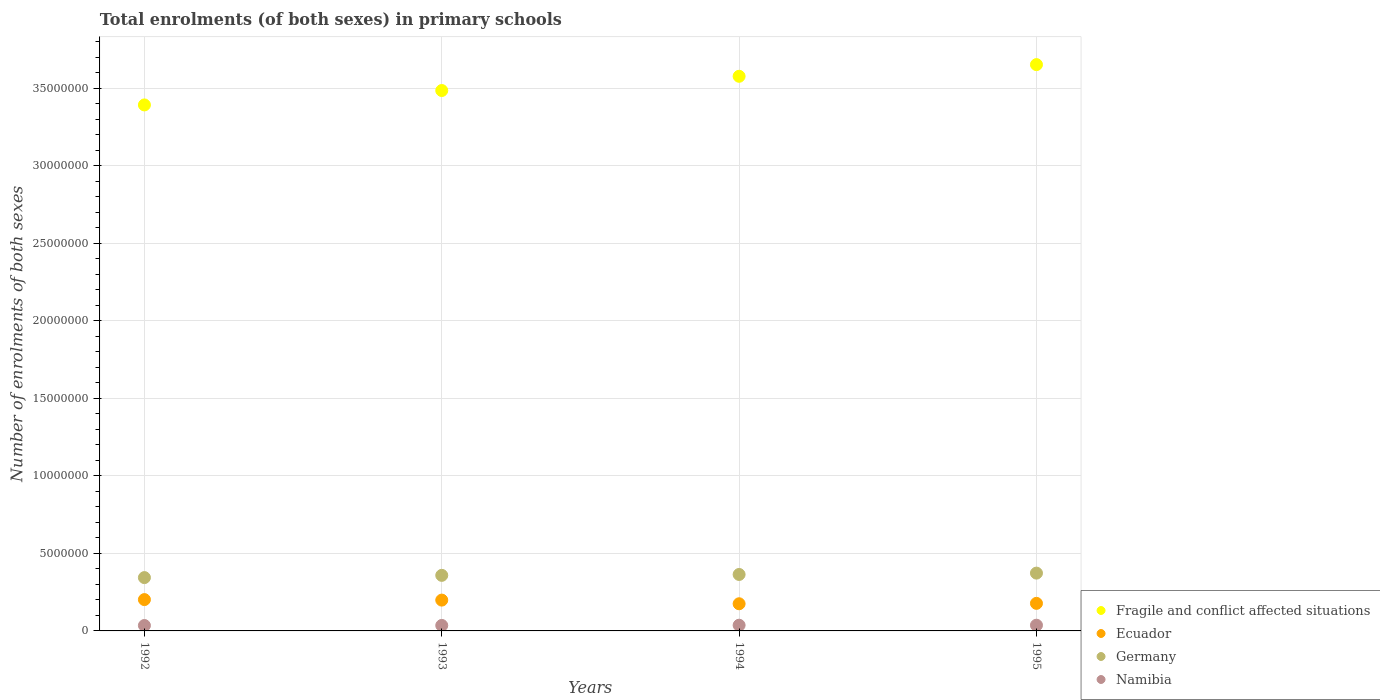How many different coloured dotlines are there?
Provide a short and direct response. 4. What is the number of enrolments in primary schools in Fragile and conflict affected situations in 1994?
Make the answer very short. 3.58e+07. Across all years, what is the maximum number of enrolments in primary schools in Ecuador?
Your answer should be very brief. 2.02e+06. Across all years, what is the minimum number of enrolments in primary schools in Namibia?
Your answer should be very brief. 3.49e+05. In which year was the number of enrolments in primary schools in Germany maximum?
Make the answer very short. 1995. In which year was the number of enrolments in primary schools in Ecuador minimum?
Give a very brief answer. 1994. What is the total number of enrolments in primary schools in Ecuador in the graph?
Keep it short and to the point. 7.54e+06. What is the difference between the number of enrolments in primary schools in Namibia in 1993 and that in 1994?
Your response must be concise. -1.48e+04. What is the difference between the number of enrolments in primary schools in Fragile and conflict affected situations in 1994 and the number of enrolments in primary schools in Namibia in 1995?
Provide a short and direct response. 3.54e+07. What is the average number of enrolments in primary schools in Namibia per year?
Keep it short and to the point. 3.59e+05. In the year 1992, what is the difference between the number of enrolments in primary schools in Ecuador and number of enrolments in primary schools in Germany?
Offer a terse response. -1.42e+06. In how many years, is the number of enrolments in primary schools in Namibia greater than 3000000?
Your response must be concise. 0. What is the ratio of the number of enrolments in primary schools in Germany in 1994 to that in 1995?
Offer a terse response. 0.98. Is the number of enrolments in primary schools in Ecuador in 1992 less than that in 1995?
Keep it short and to the point. No. Is the difference between the number of enrolments in primary schools in Ecuador in 1994 and 1995 greater than the difference between the number of enrolments in primary schools in Germany in 1994 and 1995?
Make the answer very short. Yes. What is the difference between the highest and the second highest number of enrolments in primary schools in Fragile and conflict affected situations?
Your answer should be compact. 7.52e+05. What is the difference between the highest and the lowest number of enrolments in primary schools in Ecuador?
Your response must be concise. 2.69e+05. In how many years, is the number of enrolments in primary schools in Germany greater than the average number of enrolments in primary schools in Germany taken over all years?
Your response must be concise. 2. Is the sum of the number of enrolments in primary schools in Ecuador in 1994 and 1995 greater than the maximum number of enrolments in primary schools in Fragile and conflict affected situations across all years?
Provide a short and direct response. No. Is it the case that in every year, the sum of the number of enrolments in primary schools in Ecuador and number of enrolments in primary schools in Namibia  is greater than the sum of number of enrolments in primary schools in Fragile and conflict affected situations and number of enrolments in primary schools in Germany?
Offer a terse response. No. Is the number of enrolments in primary schools in Germany strictly greater than the number of enrolments in primary schools in Namibia over the years?
Your response must be concise. Yes. What is the difference between two consecutive major ticks on the Y-axis?
Ensure brevity in your answer.  5.00e+06. Are the values on the major ticks of Y-axis written in scientific E-notation?
Keep it short and to the point. No. Does the graph contain any zero values?
Your answer should be very brief. No. How many legend labels are there?
Your response must be concise. 4. How are the legend labels stacked?
Keep it short and to the point. Vertical. What is the title of the graph?
Make the answer very short. Total enrolments (of both sexes) in primary schools. What is the label or title of the X-axis?
Provide a succinct answer. Years. What is the label or title of the Y-axis?
Provide a succinct answer. Number of enrolments of both sexes. What is the Number of enrolments of both sexes of Fragile and conflict affected situations in 1992?
Ensure brevity in your answer.  3.39e+07. What is the Number of enrolments of both sexes of Ecuador in 1992?
Offer a very short reply. 2.02e+06. What is the Number of enrolments of both sexes of Germany in 1992?
Offer a very short reply. 3.44e+06. What is the Number of enrolments of both sexes in Namibia in 1992?
Your response must be concise. 3.49e+05. What is the Number of enrolments of both sexes of Fragile and conflict affected situations in 1993?
Provide a short and direct response. 3.48e+07. What is the Number of enrolments of both sexes in Ecuador in 1993?
Your answer should be very brief. 1.99e+06. What is the Number of enrolments of both sexes in Germany in 1993?
Make the answer very short. 3.58e+06. What is the Number of enrolments of both sexes of Namibia in 1993?
Offer a very short reply. 3.53e+05. What is the Number of enrolments of both sexes in Fragile and conflict affected situations in 1994?
Ensure brevity in your answer.  3.58e+07. What is the Number of enrolments of both sexes in Ecuador in 1994?
Your answer should be very brief. 1.75e+06. What is the Number of enrolments of both sexes in Germany in 1994?
Your answer should be compact. 3.64e+06. What is the Number of enrolments of both sexes in Namibia in 1994?
Give a very brief answer. 3.68e+05. What is the Number of enrolments of both sexes in Fragile and conflict affected situations in 1995?
Offer a terse response. 3.65e+07. What is the Number of enrolments of both sexes in Ecuador in 1995?
Provide a short and direct response. 1.78e+06. What is the Number of enrolments of both sexes in Germany in 1995?
Offer a terse response. 3.73e+06. What is the Number of enrolments of both sexes in Namibia in 1995?
Your answer should be compact. 3.68e+05. Across all years, what is the maximum Number of enrolments of both sexes in Fragile and conflict affected situations?
Make the answer very short. 3.65e+07. Across all years, what is the maximum Number of enrolments of both sexes in Ecuador?
Your answer should be compact. 2.02e+06. Across all years, what is the maximum Number of enrolments of both sexes in Germany?
Provide a succinct answer. 3.73e+06. Across all years, what is the maximum Number of enrolments of both sexes of Namibia?
Provide a succinct answer. 3.68e+05. Across all years, what is the minimum Number of enrolments of both sexes in Fragile and conflict affected situations?
Provide a succinct answer. 3.39e+07. Across all years, what is the minimum Number of enrolments of both sexes of Ecuador?
Keep it short and to the point. 1.75e+06. Across all years, what is the minimum Number of enrolments of both sexes in Germany?
Give a very brief answer. 3.44e+06. Across all years, what is the minimum Number of enrolments of both sexes in Namibia?
Provide a succinct answer. 3.49e+05. What is the total Number of enrolments of both sexes of Fragile and conflict affected situations in the graph?
Keep it short and to the point. 1.41e+08. What is the total Number of enrolments of both sexes in Ecuador in the graph?
Offer a very short reply. 7.54e+06. What is the total Number of enrolments of both sexes of Germany in the graph?
Your response must be concise. 1.44e+07. What is the total Number of enrolments of both sexes in Namibia in the graph?
Make the answer very short. 1.44e+06. What is the difference between the Number of enrolments of both sexes in Fragile and conflict affected situations in 1992 and that in 1993?
Provide a succinct answer. -9.29e+05. What is the difference between the Number of enrolments of both sexes of Ecuador in 1992 and that in 1993?
Provide a succinct answer. 3.31e+04. What is the difference between the Number of enrolments of both sexes of Germany in 1992 and that in 1993?
Make the answer very short. -1.45e+05. What is the difference between the Number of enrolments of both sexes in Namibia in 1992 and that in 1993?
Provide a succinct answer. -3733. What is the difference between the Number of enrolments of both sexes in Fragile and conflict affected situations in 1992 and that in 1994?
Ensure brevity in your answer.  -1.85e+06. What is the difference between the Number of enrolments of both sexes of Ecuador in 1992 and that in 1994?
Give a very brief answer. 2.69e+05. What is the difference between the Number of enrolments of both sexes in Germany in 1992 and that in 1994?
Give a very brief answer. -2.02e+05. What is the difference between the Number of enrolments of both sexes in Namibia in 1992 and that in 1994?
Offer a very short reply. -1.85e+04. What is the difference between the Number of enrolments of both sexes of Fragile and conflict affected situations in 1992 and that in 1995?
Ensure brevity in your answer.  -2.60e+06. What is the difference between the Number of enrolments of both sexes of Ecuador in 1992 and that in 1995?
Make the answer very short. 2.43e+05. What is the difference between the Number of enrolments of both sexes in Germany in 1992 and that in 1995?
Provide a short and direct response. -2.89e+05. What is the difference between the Number of enrolments of both sexes in Namibia in 1992 and that in 1995?
Give a very brief answer. -1.91e+04. What is the difference between the Number of enrolments of both sexes in Fragile and conflict affected situations in 1993 and that in 1994?
Ensure brevity in your answer.  -9.18e+05. What is the difference between the Number of enrolments of both sexes of Ecuador in 1993 and that in 1994?
Your response must be concise. 2.36e+05. What is the difference between the Number of enrolments of both sexes in Germany in 1993 and that in 1994?
Your answer should be compact. -5.71e+04. What is the difference between the Number of enrolments of both sexes of Namibia in 1993 and that in 1994?
Provide a succinct answer. -1.48e+04. What is the difference between the Number of enrolments of both sexes in Fragile and conflict affected situations in 1993 and that in 1995?
Make the answer very short. -1.67e+06. What is the difference between the Number of enrolments of both sexes in Ecuador in 1993 and that in 1995?
Your response must be concise. 2.09e+05. What is the difference between the Number of enrolments of both sexes in Germany in 1993 and that in 1995?
Make the answer very short. -1.45e+05. What is the difference between the Number of enrolments of both sexes of Namibia in 1993 and that in 1995?
Keep it short and to the point. -1.53e+04. What is the difference between the Number of enrolments of both sexes in Fragile and conflict affected situations in 1994 and that in 1995?
Ensure brevity in your answer.  -7.52e+05. What is the difference between the Number of enrolments of both sexes of Ecuador in 1994 and that in 1995?
Keep it short and to the point. -2.62e+04. What is the difference between the Number of enrolments of both sexes in Germany in 1994 and that in 1995?
Your answer should be compact. -8.74e+04. What is the difference between the Number of enrolments of both sexes of Namibia in 1994 and that in 1995?
Provide a short and direct response. -553. What is the difference between the Number of enrolments of both sexes in Fragile and conflict affected situations in 1992 and the Number of enrolments of both sexes in Ecuador in 1993?
Make the answer very short. 3.19e+07. What is the difference between the Number of enrolments of both sexes in Fragile and conflict affected situations in 1992 and the Number of enrolments of both sexes in Germany in 1993?
Make the answer very short. 3.03e+07. What is the difference between the Number of enrolments of both sexes in Fragile and conflict affected situations in 1992 and the Number of enrolments of both sexes in Namibia in 1993?
Offer a very short reply. 3.36e+07. What is the difference between the Number of enrolments of both sexes of Ecuador in 1992 and the Number of enrolments of both sexes of Germany in 1993?
Offer a terse response. -1.56e+06. What is the difference between the Number of enrolments of both sexes of Ecuador in 1992 and the Number of enrolments of both sexes of Namibia in 1993?
Give a very brief answer. 1.67e+06. What is the difference between the Number of enrolments of both sexes of Germany in 1992 and the Number of enrolments of both sexes of Namibia in 1993?
Give a very brief answer. 3.09e+06. What is the difference between the Number of enrolments of both sexes of Fragile and conflict affected situations in 1992 and the Number of enrolments of both sexes of Ecuador in 1994?
Give a very brief answer. 3.22e+07. What is the difference between the Number of enrolments of both sexes of Fragile and conflict affected situations in 1992 and the Number of enrolments of both sexes of Germany in 1994?
Give a very brief answer. 3.03e+07. What is the difference between the Number of enrolments of both sexes in Fragile and conflict affected situations in 1992 and the Number of enrolments of both sexes in Namibia in 1994?
Make the answer very short. 3.35e+07. What is the difference between the Number of enrolments of both sexes of Ecuador in 1992 and the Number of enrolments of both sexes of Germany in 1994?
Your answer should be compact. -1.62e+06. What is the difference between the Number of enrolments of both sexes of Ecuador in 1992 and the Number of enrolments of both sexes of Namibia in 1994?
Ensure brevity in your answer.  1.65e+06. What is the difference between the Number of enrolments of both sexes in Germany in 1992 and the Number of enrolments of both sexes in Namibia in 1994?
Give a very brief answer. 3.07e+06. What is the difference between the Number of enrolments of both sexes of Fragile and conflict affected situations in 1992 and the Number of enrolments of both sexes of Ecuador in 1995?
Your answer should be very brief. 3.21e+07. What is the difference between the Number of enrolments of both sexes in Fragile and conflict affected situations in 1992 and the Number of enrolments of both sexes in Germany in 1995?
Ensure brevity in your answer.  3.02e+07. What is the difference between the Number of enrolments of both sexes in Fragile and conflict affected situations in 1992 and the Number of enrolments of both sexes in Namibia in 1995?
Offer a very short reply. 3.35e+07. What is the difference between the Number of enrolments of both sexes of Ecuador in 1992 and the Number of enrolments of both sexes of Germany in 1995?
Your response must be concise. -1.71e+06. What is the difference between the Number of enrolments of both sexes of Ecuador in 1992 and the Number of enrolments of both sexes of Namibia in 1995?
Provide a short and direct response. 1.65e+06. What is the difference between the Number of enrolments of both sexes of Germany in 1992 and the Number of enrolments of both sexes of Namibia in 1995?
Offer a terse response. 3.07e+06. What is the difference between the Number of enrolments of both sexes in Fragile and conflict affected situations in 1993 and the Number of enrolments of both sexes in Ecuador in 1994?
Make the answer very short. 3.31e+07. What is the difference between the Number of enrolments of both sexes in Fragile and conflict affected situations in 1993 and the Number of enrolments of both sexes in Germany in 1994?
Your answer should be compact. 3.12e+07. What is the difference between the Number of enrolments of both sexes in Fragile and conflict affected situations in 1993 and the Number of enrolments of both sexes in Namibia in 1994?
Ensure brevity in your answer.  3.45e+07. What is the difference between the Number of enrolments of both sexes in Ecuador in 1993 and the Number of enrolments of both sexes in Germany in 1994?
Make the answer very short. -1.65e+06. What is the difference between the Number of enrolments of both sexes in Ecuador in 1993 and the Number of enrolments of both sexes in Namibia in 1994?
Provide a succinct answer. 1.62e+06. What is the difference between the Number of enrolments of both sexes in Germany in 1993 and the Number of enrolments of both sexes in Namibia in 1994?
Offer a very short reply. 3.21e+06. What is the difference between the Number of enrolments of both sexes of Fragile and conflict affected situations in 1993 and the Number of enrolments of both sexes of Ecuador in 1995?
Your answer should be compact. 3.31e+07. What is the difference between the Number of enrolments of both sexes in Fragile and conflict affected situations in 1993 and the Number of enrolments of both sexes in Germany in 1995?
Offer a very short reply. 3.11e+07. What is the difference between the Number of enrolments of both sexes in Fragile and conflict affected situations in 1993 and the Number of enrolments of both sexes in Namibia in 1995?
Offer a terse response. 3.45e+07. What is the difference between the Number of enrolments of both sexes of Ecuador in 1993 and the Number of enrolments of both sexes of Germany in 1995?
Your answer should be very brief. -1.74e+06. What is the difference between the Number of enrolments of both sexes of Ecuador in 1993 and the Number of enrolments of both sexes of Namibia in 1995?
Ensure brevity in your answer.  1.62e+06. What is the difference between the Number of enrolments of both sexes of Germany in 1993 and the Number of enrolments of both sexes of Namibia in 1995?
Your answer should be compact. 3.21e+06. What is the difference between the Number of enrolments of both sexes in Fragile and conflict affected situations in 1994 and the Number of enrolments of both sexes in Ecuador in 1995?
Your answer should be very brief. 3.40e+07. What is the difference between the Number of enrolments of both sexes in Fragile and conflict affected situations in 1994 and the Number of enrolments of both sexes in Germany in 1995?
Your answer should be very brief. 3.20e+07. What is the difference between the Number of enrolments of both sexes in Fragile and conflict affected situations in 1994 and the Number of enrolments of both sexes in Namibia in 1995?
Give a very brief answer. 3.54e+07. What is the difference between the Number of enrolments of both sexes in Ecuador in 1994 and the Number of enrolments of both sexes in Germany in 1995?
Make the answer very short. -1.98e+06. What is the difference between the Number of enrolments of both sexes of Ecuador in 1994 and the Number of enrolments of both sexes of Namibia in 1995?
Your response must be concise. 1.38e+06. What is the difference between the Number of enrolments of both sexes of Germany in 1994 and the Number of enrolments of both sexes of Namibia in 1995?
Offer a very short reply. 3.27e+06. What is the average Number of enrolments of both sexes in Fragile and conflict affected situations per year?
Offer a terse response. 3.53e+07. What is the average Number of enrolments of both sexes in Ecuador per year?
Keep it short and to the point. 1.88e+06. What is the average Number of enrolments of both sexes in Germany per year?
Keep it short and to the point. 3.60e+06. What is the average Number of enrolments of both sexes in Namibia per year?
Offer a very short reply. 3.59e+05. In the year 1992, what is the difference between the Number of enrolments of both sexes in Fragile and conflict affected situations and Number of enrolments of both sexes in Ecuador?
Your answer should be compact. 3.19e+07. In the year 1992, what is the difference between the Number of enrolments of both sexes in Fragile and conflict affected situations and Number of enrolments of both sexes in Germany?
Offer a terse response. 3.05e+07. In the year 1992, what is the difference between the Number of enrolments of both sexes in Fragile and conflict affected situations and Number of enrolments of both sexes in Namibia?
Your answer should be very brief. 3.36e+07. In the year 1992, what is the difference between the Number of enrolments of both sexes of Ecuador and Number of enrolments of both sexes of Germany?
Your answer should be compact. -1.42e+06. In the year 1992, what is the difference between the Number of enrolments of both sexes in Ecuador and Number of enrolments of both sexes in Namibia?
Provide a short and direct response. 1.67e+06. In the year 1992, what is the difference between the Number of enrolments of both sexes in Germany and Number of enrolments of both sexes in Namibia?
Ensure brevity in your answer.  3.09e+06. In the year 1993, what is the difference between the Number of enrolments of both sexes of Fragile and conflict affected situations and Number of enrolments of both sexes of Ecuador?
Your answer should be compact. 3.29e+07. In the year 1993, what is the difference between the Number of enrolments of both sexes in Fragile and conflict affected situations and Number of enrolments of both sexes in Germany?
Make the answer very short. 3.13e+07. In the year 1993, what is the difference between the Number of enrolments of both sexes in Fragile and conflict affected situations and Number of enrolments of both sexes in Namibia?
Give a very brief answer. 3.45e+07. In the year 1993, what is the difference between the Number of enrolments of both sexes of Ecuador and Number of enrolments of both sexes of Germany?
Your answer should be very brief. -1.60e+06. In the year 1993, what is the difference between the Number of enrolments of both sexes of Ecuador and Number of enrolments of both sexes of Namibia?
Your answer should be compact. 1.63e+06. In the year 1993, what is the difference between the Number of enrolments of both sexes of Germany and Number of enrolments of both sexes of Namibia?
Your response must be concise. 3.23e+06. In the year 1994, what is the difference between the Number of enrolments of both sexes of Fragile and conflict affected situations and Number of enrolments of both sexes of Ecuador?
Keep it short and to the point. 3.40e+07. In the year 1994, what is the difference between the Number of enrolments of both sexes in Fragile and conflict affected situations and Number of enrolments of both sexes in Germany?
Your response must be concise. 3.21e+07. In the year 1994, what is the difference between the Number of enrolments of both sexes of Fragile and conflict affected situations and Number of enrolments of both sexes of Namibia?
Your answer should be compact. 3.54e+07. In the year 1994, what is the difference between the Number of enrolments of both sexes of Ecuador and Number of enrolments of both sexes of Germany?
Give a very brief answer. -1.89e+06. In the year 1994, what is the difference between the Number of enrolments of both sexes of Ecuador and Number of enrolments of both sexes of Namibia?
Your response must be concise. 1.38e+06. In the year 1994, what is the difference between the Number of enrolments of both sexes of Germany and Number of enrolments of both sexes of Namibia?
Keep it short and to the point. 3.27e+06. In the year 1995, what is the difference between the Number of enrolments of both sexes in Fragile and conflict affected situations and Number of enrolments of both sexes in Ecuador?
Provide a succinct answer. 3.47e+07. In the year 1995, what is the difference between the Number of enrolments of both sexes in Fragile and conflict affected situations and Number of enrolments of both sexes in Germany?
Give a very brief answer. 3.28e+07. In the year 1995, what is the difference between the Number of enrolments of both sexes of Fragile and conflict affected situations and Number of enrolments of both sexes of Namibia?
Provide a succinct answer. 3.61e+07. In the year 1995, what is the difference between the Number of enrolments of both sexes in Ecuador and Number of enrolments of both sexes in Germany?
Your answer should be compact. -1.95e+06. In the year 1995, what is the difference between the Number of enrolments of both sexes of Ecuador and Number of enrolments of both sexes of Namibia?
Provide a succinct answer. 1.41e+06. In the year 1995, what is the difference between the Number of enrolments of both sexes of Germany and Number of enrolments of both sexes of Namibia?
Provide a succinct answer. 3.36e+06. What is the ratio of the Number of enrolments of both sexes of Fragile and conflict affected situations in 1992 to that in 1993?
Ensure brevity in your answer.  0.97. What is the ratio of the Number of enrolments of both sexes of Ecuador in 1992 to that in 1993?
Make the answer very short. 1.02. What is the ratio of the Number of enrolments of both sexes in Germany in 1992 to that in 1993?
Ensure brevity in your answer.  0.96. What is the ratio of the Number of enrolments of both sexes in Fragile and conflict affected situations in 1992 to that in 1994?
Make the answer very short. 0.95. What is the ratio of the Number of enrolments of both sexes of Ecuador in 1992 to that in 1994?
Provide a succinct answer. 1.15. What is the ratio of the Number of enrolments of both sexes in Germany in 1992 to that in 1994?
Your answer should be very brief. 0.94. What is the ratio of the Number of enrolments of both sexes of Namibia in 1992 to that in 1994?
Your answer should be compact. 0.95. What is the ratio of the Number of enrolments of both sexes of Fragile and conflict affected situations in 1992 to that in 1995?
Your response must be concise. 0.93. What is the ratio of the Number of enrolments of both sexes in Ecuador in 1992 to that in 1995?
Your answer should be compact. 1.14. What is the ratio of the Number of enrolments of both sexes of Germany in 1992 to that in 1995?
Offer a very short reply. 0.92. What is the ratio of the Number of enrolments of both sexes of Namibia in 1992 to that in 1995?
Your answer should be very brief. 0.95. What is the ratio of the Number of enrolments of both sexes of Fragile and conflict affected situations in 1993 to that in 1994?
Your response must be concise. 0.97. What is the ratio of the Number of enrolments of both sexes of Ecuador in 1993 to that in 1994?
Your answer should be compact. 1.13. What is the ratio of the Number of enrolments of both sexes in Germany in 1993 to that in 1994?
Make the answer very short. 0.98. What is the ratio of the Number of enrolments of both sexes of Namibia in 1993 to that in 1994?
Offer a terse response. 0.96. What is the ratio of the Number of enrolments of both sexes of Fragile and conflict affected situations in 1993 to that in 1995?
Your answer should be very brief. 0.95. What is the ratio of the Number of enrolments of both sexes of Ecuador in 1993 to that in 1995?
Your response must be concise. 1.12. What is the ratio of the Number of enrolments of both sexes of Germany in 1993 to that in 1995?
Keep it short and to the point. 0.96. What is the ratio of the Number of enrolments of both sexes in Namibia in 1993 to that in 1995?
Your answer should be compact. 0.96. What is the ratio of the Number of enrolments of both sexes of Fragile and conflict affected situations in 1994 to that in 1995?
Keep it short and to the point. 0.98. What is the ratio of the Number of enrolments of both sexes in Germany in 1994 to that in 1995?
Your answer should be very brief. 0.98. What is the ratio of the Number of enrolments of both sexes of Namibia in 1994 to that in 1995?
Ensure brevity in your answer.  1. What is the difference between the highest and the second highest Number of enrolments of both sexes in Fragile and conflict affected situations?
Offer a terse response. 7.52e+05. What is the difference between the highest and the second highest Number of enrolments of both sexes of Ecuador?
Provide a short and direct response. 3.31e+04. What is the difference between the highest and the second highest Number of enrolments of both sexes of Germany?
Keep it short and to the point. 8.74e+04. What is the difference between the highest and the second highest Number of enrolments of both sexes of Namibia?
Your answer should be very brief. 553. What is the difference between the highest and the lowest Number of enrolments of both sexes of Fragile and conflict affected situations?
Your answer should be compact. 2.60e+06. What is the difference between the highest and the lowest Number of enrolments of both sexes in Ecuador?
Ensure brevity in your answer.  2.69e+05. What is the difference between the highest and the lowest Number of enrolments of both sexes in Germany?
Keep it short and to the point. 2.89e+05. What is the difference between the highest and the lowest Number of enrolments of both sexes of Namibia?
Keep it short and to the point. 1.91e+04. 